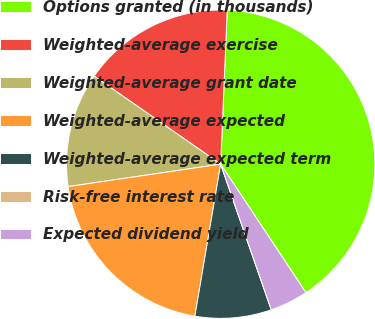Convert chart. <chart><loc_0><loc_0><loc_500><loc_500><pie_chart><fcel>Options granted (in thousands)<fcel>Weighted-average exercise<fcel>Weighted-average grant date<fcel>Weighted-average expected<fcel>Weighted-average expected term<fcel>Risk-free interest rate<fcel>Expected dividend yield<nl><fcel>40.0%<fcel>16.0%<fcel>12.0%<fcel>20.0%<fcel>8.0%<fcel>0.0%<fcel>4.0%<nl></chart> 